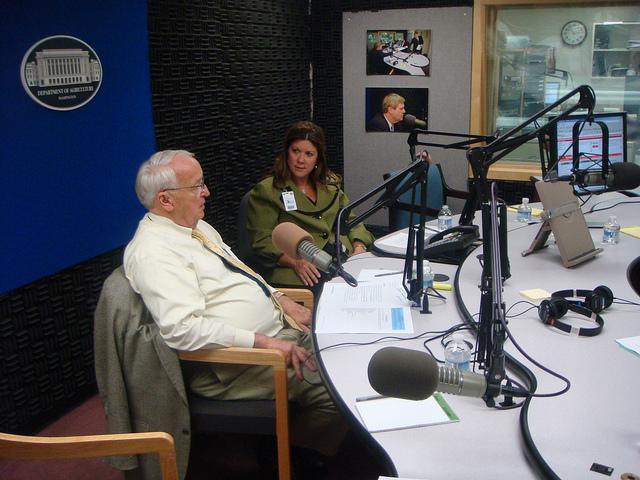How many bottled waters are there on the table?
Give a very brief answer. 5. How many microphones are visible?
Give a very brief answer. 4. How many chairs are in the photo?
Give a very brief answer. 3. How many people are there?
Give a very brief answer. 2. How many black remotes are on the table?
Give a very brief answer. 0. 